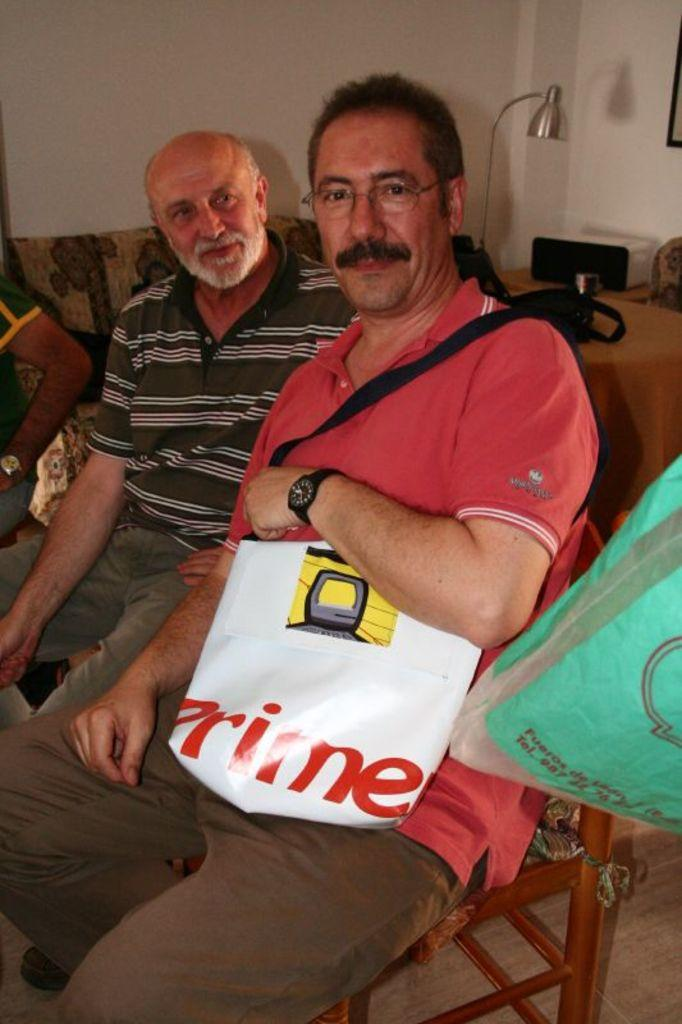How many people are in the image? There are two men in the image. What are the men doing in the image? The men are seated on chairs. What is the person on the right side holding? The person on the right side is holding a bag. What can be seen in the background of the image? There is a light and other things on a table in the background of the image. What type of mist can be seen surrounding the men in the image? There is no mist present in the image; it is a clear scene with a light in the background. What is the temper of the person on the left side in the image? There is no indication of the person's temper in the image; we can only observe their actions and what they are holding. 